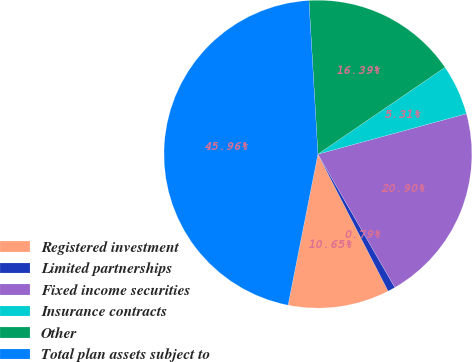Convert chart to OTSL. <chart><loc_0><loc_0><loc_500><loc_500><pie_chart><fcel>Registered investment<fcel>Limited partnerships<fcel>Fixed income securities<fcel>Insurance contracts<fcel>Other<fcel>Total plan assets subject to<nl><fcel>10.65%<fcel>0.79%<fcel>20.9%<fcel>5.31%<fcel>16.39%<fcel>45.96%<nl></chart> 